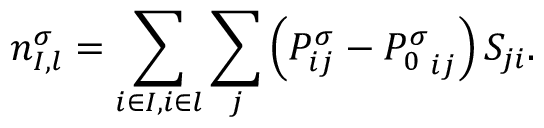<formula> <loc_0><loc_0><loc_500><loc_500>n _ { I , l } ^ { \sigma } = \sum _ { i \in I , i \in l } \sum _ { j } \left ( P _ { i j } ^ { \sigma } - { P _ { 0 } ^ { \sigma } } _ { i j } \right ) S _ { j i } .</formula> 